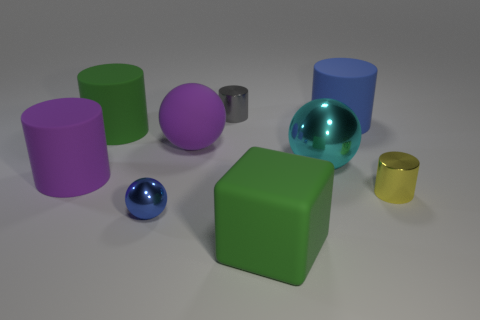Add 1 purple cylinders. How many objects exist? 10 Subtract all purple matte cylinders. How many cylinders are left? 4 Subtract 2 spheres. How many spheres are left? 1 Subtract all red spheres. How many blue blocks are left? 0 Subtract all tiny gray objects. Subtract all small blue metallic spheres. How many objects are left? 7 Add 6 big purple rubber spheres. How many big purple rubber spheres are left? 7 Add 2 large purple matte objects. How many large purple matte objects exist? 4 Subtract all blue cylinders. How many cylinders are left? 4 Subtract 0 green balls. How many objects are left? 9 Subtract all blocks. How many objects are left? 8 